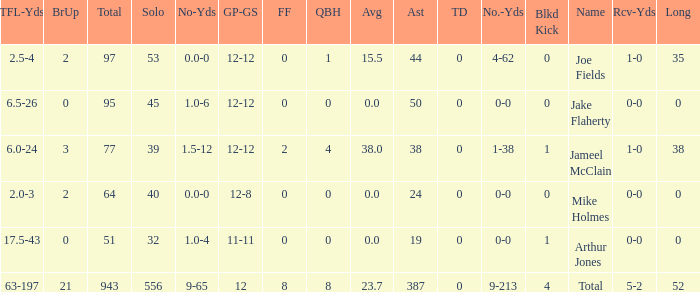What is the total brup for the team? 21.0. Would you mind parsing the complete table? {'header': ['TFL-Yds', 'BrUp', 'Total', 'Solo', 'No-Yds', 'GP-GS', 'FF', 'QBH', 'Avg', 'Ast', 'TD', 'No.-Yds', 'Blkd Kick', 'Name', 'Rcv-Yds', 'Long'], 'rows': [['2.5-4', '2', '97', '53', '0.0-0', '12-12', '0', '1', '15.5', '44', '0', '4-62', '0', 'Joe Fields', '1-0', '35'], ['6.5-26', '0', '95', '45', '1.0-6', '12-12', '0', '0', '0.0', '50', '0', '0-0', '0', 'Jake Flaherty', '0-0', '0'], ['6.0-24', '3', '77', '39', '1.5-12', '12-12', '2', '4', '38.0', '38', '0', '1-38', '1', 'Jameel McClain', '1-0', '38'], ['2.0-3', '2', '64', '40', '0.0-0', '12-8', '0', '0', '0.0', '24', '0', '0-0', '0', 'Mike Holmes', '0-0', '0'], ['17.5-43', '0', '51', '32', '1.0-4', '11-11', '0', '0', '0.0', '19', '0', '0-0', '1', 'Arthur Jones', '0-0', '0'], ['63-197', '21', '943', '556', '9-65', '12', '8', '8', '23.7', '387', '0', '9-213', '4', 'Total', '5-2', '52']]} 